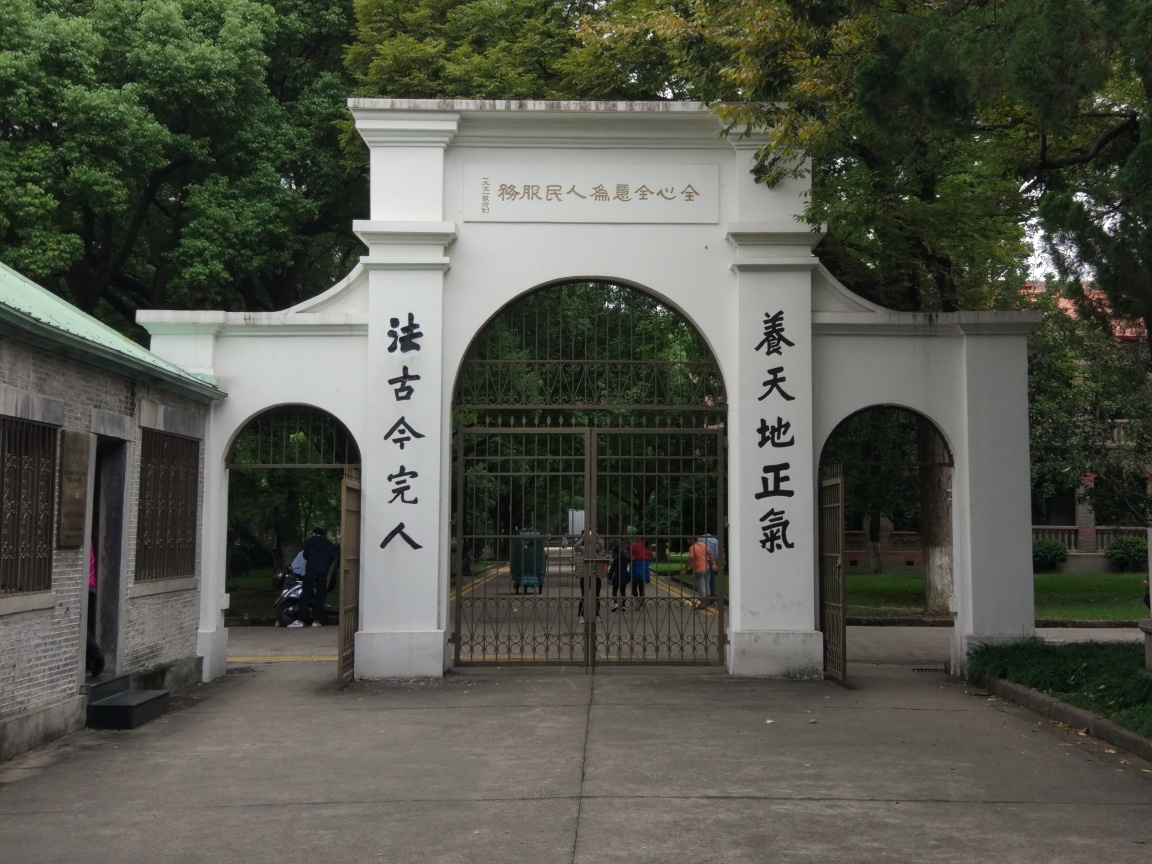Is the image distorted or warped?
A. No
B. Yes
Answer with the option's letter from the given choices directly.
 A. 